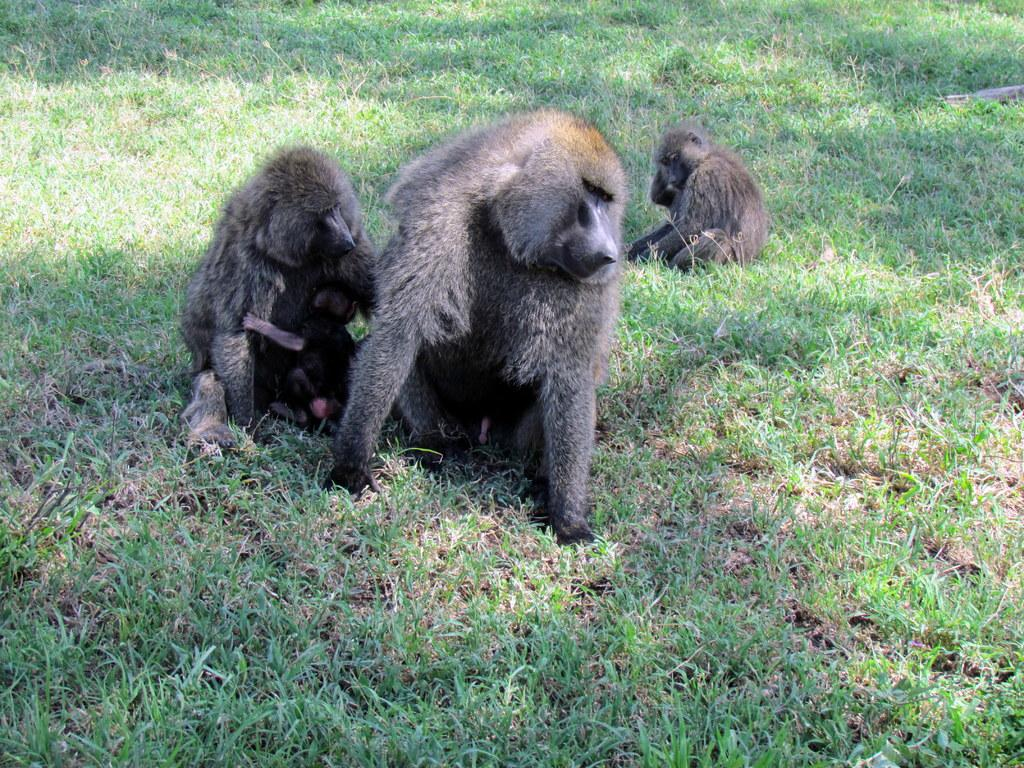What type of living organisms can be seen in the image? There are animals in the image. Where are the animals located in the image? The animals are sitting on the grass. How many geese are sitting in the pocket in the image? There are no geese or pockets present in the image. 